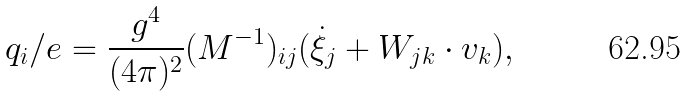<formula> <loc_0><loc_0><loc_500><loc_500>q _ { i } / e = \frac { g ^ { 4 } } { ( 4 \pi ) ^ { 2 } } ( M ^ { - 1 } ) _ { i j } ( \dot { \xi } _ { j } + W _ { j k } \cdot v _ { k } ) ,</formula> 